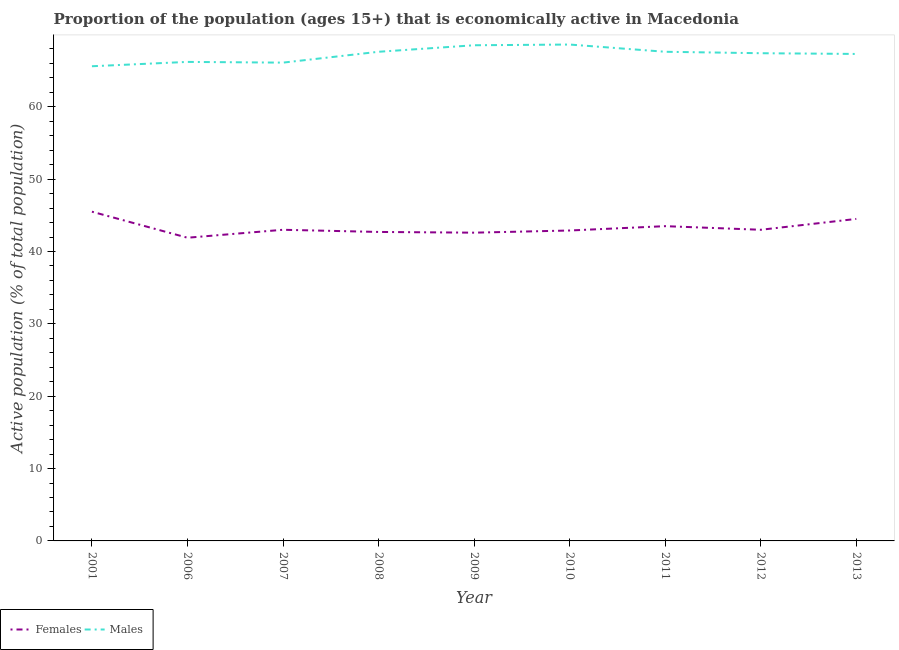How many different coloured lines are there?
Your response must be concise. 2. Does the line corresponding to percentage of economically active female population intersect with the line corresponding to percentage of economically active male population?
Provide a succinct answer. No. Is the number of lines equal to the number of legend labels?
Your answer should be compact. Yes. What is the percentage of economically active female population in 2011?
Make the answer very short. 43.5. Across all years, what is the maximum percentage of economically active male population?
Provide a succinct answer. 68.6. Across all years, what is the minimum percentage of economically active male population?
Offer a terse response. 65.6. In which year was the percentage of economically active female population maximum?
Provide a short and direct response. 2001. In which year was the percentage of economically active female population minimum?
Give a very brief answer. 2006. What is the total percentage of economically active male population in the graph?
Give a very brief answer. 604.9. What is the difference between the percentage of economically active male population in 2008 and that in 2013?
Ensure brevity in your answer.  0.3. What is the difference between the percentage of economically active male population in 2009 and the percentage of economically active female population in 2006?
Make the answer very short. 26.6. What is the average percentage of economically active female population per year?
Offer a terse response. 43.29. In the year 2012, what is the difference between the percentage of economically active male population and percentage of economically active female population?
Offer a very short reply. 24.4. What is the ratio of the percentage of economically active female population in 2008 to that in 2010?
Offer a terse response. 1. What is the difference between the highest and the second highest percentage of economically active male population?
Give a very brief answer. 0.1. What is the difference between the highest and the lowest percentage of economically active male population?
Ensure brevity in your answer.  3. In how many years, is the percentage of economically active male population greater than the average percentage of economically active male population taken over all years?
Make the answer very short. 6. Does the percentage of economically active male population monotonically increase over the years?
Give a very brief answer. No. Is the percentage of economically active male population strictly greater than the percentage of economically active female population over the years?
Keep it short and to the point. Yes. How many years are there in the graph?
Your answer should be compact. 9. What is the difference between two consecutive major ticks on the Y-axis?
Keep it short and to the point. 10. Does the graph contain any zero values?
Your response must be concise. No. Does the graph contain grids?
Your answer should be compact. No. Where does the legend appear in the graph?
Provide a succinct answer. Bottom left. What is the title of the graph?
Make the answer very short. Proportion of the population (ages 15+) that is economically active in Macedonia. Does "Electricity and heat production" appear as one of the legend labels in the graph?
Your answer should be compact. No. What is the label or title of the Y-axis?
Keep it short and to the point. Active population (% of total population). What is the Active population (% of total population) of Females in 2001?
Ensure brevity in your answer.  45.5. What is the Active population (% of total population) of Males in 2001?
Keep it short and to the point. 65.6. What is the Active population (% of total population) in Females in 2006?
Provide a short and direct response. 41.9. What is the Active population (% of total population) in Males in 2006?
Give a very brief answer. 66.2. What is the Active population (% of total population) of Females in 2007?
Offer a very short reply. 43. What is the Active population (% of total population) of Males in 2007?
Your answer should be very brief. 66.1. What is the Active population (% of total population) of Females in 2008?
Your answer should be compact. 42.7. What is the Active population (% of total population) of Males in 2008?
Your answer should be very brief. 67.6. What is the Active population (% of total population) in Females in 2009?
Make the answer very short. 42.6. What is the Active population (% of total population) in Males in 2009?
Provide a short and direct response. 68.5. What is the Active population (% of total population) of Females in 2010?
Ensure brevity in your answer.  42.9. What is the Active population (% of total population) in Males in 2010?
Provide a short and direct response. 68.6. What is the Active population (% of total population) in Females in 2011?
Ensure brevity in your answer.  43.5. What is the Active population (% of total population) of Males in 2011?
Your answer should be very brief. 67.6. What is the Active population (% of total population) of Females in 2012?
Offer a terse response. 43. What is the Active population (% of total population) in Males in 2012?
Make the answer very short. 67.4. What is the Active population (% of total population) of Females in 2013?
Offer a very short reply. 44.5. What is the Active population (% of total population) of Males in 2013?
Make the answer very short. 67.3. Across all years, what is the maximum Active population (% of total population) in Females?
Make the answer very short. 45.5. Across all years, what is the maximum Active population (% of total population) in Males?
Your answer should be compact. 68.6. Across all years, what is the minimum Active population (% of total population) in Females?
Offer a terse response. 41.9. Across all years, what is the minimum Active population (% of total population) of Males?
Provide a succinct answer. 65.6. What is the total Active population (% of total population) in Females in the graph?
Your response must be concise. 389.6. What is the total Active population (% of total population) of Males in the graph?
Provide a succinct answer. 604.9. What is the difference between the Active population (% of total population) of Females in 2001 and that in 2006?
Provide a short and direct response. 3.6. What is the difference between the Active population (% of total population) in Females in 2001 and that in 2007?
Your answer should be compact. 2.5. What is the difference between the Active population (% of total population) in Females in 2001 and that in 2008?
Provide a succinct answer. 2.8. What is the difference between the Active population (% of total population) of Males in 2001 and that in 2008?
Offer a terse response. -2. What is the difference between the Active population (% of total population) of Females in 2001 and that in 2012?
Give a very brief answer. 2.5. What is the difference between the Active population (% of total population) of Males in 2001 and that in 2012?
Provide a succinct answer. -1.8. What is the difference between the Active population (% of total population) of Males in 2001 and that in 2013?
Offer a very short reply. -1.7. What is the difference between the Active population (% of total population) in Males in 2006 and that in 2007?
Give a very brief answer. 0.1. What is the difference between the Active population (% of total population) in Males in 2006 and that in 2008?
Your answer should be very brief. -1.4. What is the difference between the Active population (% of total population) of Females in 2006 and that in 2009?
Make the answer very short. -0.7. What is the difference between the Active population (% of total population) of Males in 2006 and that in 2010?
Make the answer very short. -2.4. What is the difference between the Active population (% of total population) of Females in 2006 and that in 2012?
Make the answer very short. -1.1. What is the difference between the Active population (% of total population) in Males in 2006 and that in 2012?
Provide a succinct answer. -1.2. What is the difference between the Active population (% of total population) in Males in 2006 and that in 2013?
Provide a succinct answer. -1.1. What is the difference between the Active population (% of total population) of Females in 2007 and that in 2008?
Ensure brevity in your answer.  0.3. What is the difference between the Active population (% of total population) of Females in 2007 and that in 2010?
Your answer should be compact. 0.1. What is the difference between the Active population (% of total population) of Males in 2007 and that in 2011?
Provide a succinct answer. -1.5. What is the difference between the Active population (% of total population) of Females in 2007 and that in 2012?
Provide a short and direct response. 0. What is the difference between the Active population (% of total population) of Males in 2007 and that in 2012?
Keep it short and to the point. -1.3. What is the difference between the Active population (% of total population) in Females in 2007 and that in 2013?
Make the answer very short. -1.5. What is the difference between the Active population (% of total population) in Males in 2007 and that in 2013?
Ensure brevity in your answer.  -1.2. What is the difference between the Active population (% of total population) of Females in 2008 and that in 2009?
Your answer should be compact. 0.1. What is the difference between the Active population (% of total population) in Females in 2008 and that in 2011?
Your response must be concise. -0.8. What is the difference between the Active population (% of total population) in Males in 2008 and that in 2013?
Offer a very short reply. 0.3. What is the difference between the Active population (% of total population) in Males in 2009 and that in 2013?
Ensure brevity in your answer.  1.2. What is the difference between the Active population (% of total population) in Females in 2010 and that in 2011?
Your answer should be very brief. -0.6. What is the difference between the Active population (% of total population) in Males in 2010 and that in 2011?
Offer a very short reply. 1. What is the difference between the Active population (% of total population) of Males in 2010 and that in 2013?
Make the answer very short. 1.3. What is the difference between the Active population (% of total population) in Males in 2011 and that in 2012?
Keep it short and to the point. 0.2. What is the difference between the Active population (% of total population) of Females in 2011 and that in 2013?
Keep it short and to the point. -1. What is the difference between the Active population (% of total population) in Males in 2012 and that in 2013?
Give a very brief answer. 0.1. What is the difference between the Active population (% of total population) in Females in 2001 and the Active population (% of total population) in Males in 2006?
Give a very brief answer. -20.7. What is the difference between the Active population (% of total population) in Females in 2001 and the Active population (% of total population) in Males in 2007?
Offer a terse response. -20.6. What is the difference between the Active population (% of total population) in Females in 2001 and the Active population (% of total population) in Males in 2008?
Your response must be concise. -22.1. What is the difference between the Active population (% of total population) of Females in 2001 and the Active population (% of total population) of Males in 2010?
Ensure brevity in your answer.  -23.1. What is the difference between the Active population (% of total population) in Females in 2001 and the Active population (% of total population) in Males in 2011?
Your answer should be compact. -22.1. What is the difference between the Active population (% of total population) in Females in 2001 and the Active population (% of total population) in Males in 2012?
Ensure brevity in your answer.  -21.9. What is the difference between the Active population (% of total population) in Females in 2001 and the Active population (% of total population) in Males in 2013?
Provide a succinct answer. -21.8. What is the difference between the Active population (% of total population) in Females in 2006 and the Active population (% of total population) in Males in 2007?
Ensure brevity in your answer.  -24.2. What is the difference between the Active population (% of total population) in Females in 2006 and the Active population (% of total population) in Males in 2008?
Your answer should be compact. -25.7. What is the difference between the Active population (% of total population) of Females in 2006 and the Active population (% of total population) of Males in 2009?
Offer a very short reply. -26.6. What is the difference between the Active population (% of total population) in Females in 2006 and the Active population (% of total population) in Males in 2010?
Offer a very short reply. -26.7. What is the difference between the Active population (% of total population) of Females in 2006 and the Active population (% of total population) of Males in 2011?
Ensure brevity in your answer.  -25.7. What is the difference between the Active population (% of total population) in Females in 2006 and the Active population (% of total population) in Males in 2012?
Provide a succinct answer. -25.5. What is the difference between the Active population (% of total population) of Females in 2006 and the Active population (% of total population) of Males in 2013?
Keep it short and to the point. -25.4. What is the difference between the Active population (% of total population) in Females in 2007 and the Active population (% of total population) in Males in 2008?
Offer a very short reply. -24.6. What is the difference between the Active population (% of total population) in Females in 2007 and the Active population (% of total population) in Males in 2009?
Your response must be concise. -25.5. What is the difference between the Active population (% of total population) in Females in 2007 and the Active population (% of total population) in Males in 2010?
Your response must be concise. -25.6. What is the difference between the Active population (% of total population) of Females in 2007 and the Active population (% of total population) of Males in 2011?
Give a very brief answer. -24.6. What is the difference between the Active population (% of total population) in Females in 2007 and the Active population (% of total population) in Males in 2012?
Give a very brief answer. -24.4. What is the difference between the Active population (% of total population) in Females in 2007 and the Active population (% of total population) in Males in 2013?
Your response must be concise. -24.3. What is the difference between the Active population (% of total population) in Females in 2008 and the Active population (% of total population) in Males in 2009?
Your answer should be very brief. -25.8. What is the difference between the Active population (% of total population) of Females in 2008 and the Active population (% of total population) of Males in 2010?
Make the answer very short. -25.9. What is the difference between the Active population (% of total population) of Females in 2008 and the Active population (% of total population) of Males in 2011?
Provide a succinct answer. -24.9. What is the difference between the Active population (% of total population) in Females in 2008 and the Active population (% of total population) in Males in 2012?
Your answer should be very brief. -24.7. What is the difference between the Active population (% of total population) in Females in 2008 and the Active population (% of total population) in Males in 2013?
Your response must be concise. -24.6. What is the difference between the Active population (% of total population) of Females in 2009 and the Active population (% of total population) of Males in 2010?
Offer a very short reply. -26. What is the difference between the Active population (% of total population) of Females in 2009 and the Active population (% of total population) of Males in 2012?
Offer a terse response. -24.8. What is the difference between the Active population (% of total population) in Females in 2009 and the Active population (% of total population) in Males in 2013?
Offer a very short reply. -24.7. What is the difference between the Active population (% of total population) in Females in 2010 and the Active population (% of total population) in Males in 2011?
Offer a terse response. -24.7. What is the difference between the Active population (% of total population) in Females in 2010 and the Active population (% of total population) in Males in 2012?
Provide a succinct answer. -24.5. What is the difference between the Active population (% of total population) in Females in 2010 and the Active population (% of total population) in Males in 2013?
Make the answer very short. -24.4. What is the difference between the Active population (% of total population) in Females in 2011 and the Active population (% of total population) in Males in 2012?
Make the answer very short. -23.9. What is the difference between the Active population (% of total population) in Females in 2011 and the Active population (% of total population) in Males in 2013?
Provide a succinct answer. -23.8. What is the difference between the Active population (% of total population) of Females in 2012 and the Active population (% of total population) of Males in 2013?
Offer a terse response. -24.3. What is the average Active population (% of total population) of Females per year?
Your answer should be compact. 43.29. What is the average Active population (% of total population) of Males per year?
Give a very brief answer. 67.21. In the year 2001, what is the difference between the Active population (% of total population) of Females and Active population (% of total population) of Males?
Give a very brief answer. -20.1. In the year 2006, what is the difference between the Active population (% of total population) of Females and Active population (% of total population) of Males?
Provide a succinct answer. -24.3. In the year 2007, what is the difference between the Active population (% of total population) of Females and Active population (% of total population) of Males?
Your response must be concise. -23.1. In the year 2008, what is the difference between the Active population (% of total population) in Females and Active population (% of total population) in Males?
Give a very brief answer. -24.9. In the year 2009, what is the difference between the Active population (% of total population) of Females and Active population (% of total population) of Males?
Keep it short and to the point. -25.9. In the year 2010, what is the difference between the Active population (% of total population) in Females and Active population (% of total population) in Males?
Your answer should be very brief. -25.7. In the year 2011, what is the difference between the Active population (% of total population) of Females and Active population (% of total population) of Males?
Keep it short and to the point. -24.1. In the year 2012, what is the difference between the Active population (% of total population) in Females and Active population (% of total population) in Males?
Keep it short and to the point. -24.4. In the year 2013, what is the difference between the Active population (% of total population) of Females and Active population (% of total population) of Males?
Make the answer very short. -22.8. What is the ratio of the Active population (% of total population) in Females in 2001 to that in 2006?
Provide a short and direct response. 1.09. What is the ratio of the Active population (% of total population) in Males in 2001 to that in 2006?
Offer a very short reply. 0.99. What is the ratio of the Active population (% of total population) in Females in 2001 to that in 2007?
Provide a succinct answer. 1.06. What is the ratio of the Active population (% of total population) in Females in 2001 to that in 2008?
Provide a succinct answer. 1.07. What is the ratio of the Active population (% of total population) of Males in 2001 to that in 2008?
Your answer should be compact. 0.97. What is the ratio of the Active population (% of total population) of Females in 2001 to that in 2009?
Your response must be concise. 1.07. What is the ratio of the Active population (% of total population) of Males in 2001 to that in 2009?
Your response must be concise. 0.96. What is the ratio of the Active population (% of total population) of Females in 2001 to that in 2010?
Your answer should be compact. 1.06. What is the ratio of the Active population (% of total population) of Males in 2001 to that in 2010?
Provide a short and direct response. 0.96. What is the ratio of the Active population (% of total population) of Females in 2001 to that in 2011?
Provide a succinct answer. 1.05. What is the ratio of the Active population (% of total population) of Males in 2001 to that in 2011?
Provide a short and direct response. 0.97. What is the ratio of the Active population (% of total population) in Females in 2001 to that in 2012?
Your answer should be compact. 1.06. What is the ratio of the Active population (% of total population) of Males in 2001 to that in 2012?
Your response must be concise. 0.97. What is the ratio of the Active population (% of total population) in Females in 2001 to that in 2013?
Ensure brevity in your answer.  1.02. What is the ratio of the Active population (% of total population) in Males in 2001 to that in 2013?
Provide a succinct answer. 0.97. What is the ratio of the Active population (% of total population) of Females in 2006 to that in 2007?
Offer a very short reply. 0.97. What is the ratio of the Active population (% of total population) of Females in 2006 to that in 2008?
Offer a very short reply. 0.98. What is the ratio of the Active population (% of total population) of Males in 2006 to that in 2008?
Make the answer very short. 0.98. What is the ratio of the Active population (% of total population) of Females in 2006 to that in 2009?
Provide a succinct answer. 0.98. What is the ratio of the Active population (% of total population) in Males in 2006 to that in 2009?
Your answer should be very brief. 0.97. What is the ratio of the Active population (% of total population) of Females in 2006 to that in 2010?
Provide a succinct answer. 0.98. What is the ratio of the Active population (% of total population) of Males in 2006 to that in 2010?
Your answer should be very brief. 0.96. What is the ratio of the Active population (% of total population) of Females in 2006 to that in 2011?
Keep it short and to the point. 0.96. What is the ratio of the Active population (% of total population) in Males in 2006 to that in 2011?
Give a very brief answer. 0.98. What is the ratio of the Active population (% of total population) of Females in 2006 to that in 2012?
Keep it short and to the point. 0.97. What is the ratio of the Active population (% of total population) in Males in 2006 to that in 2012?
Your response must be concise. 0.98. What is the ratio of the Active population (% of total population) of Females in 2006 to that in 2013?
Offer a terse response. 0.94. What is the ratio of the Active population (% of total population) in Males in 2006 to that in 2013?
Make the answer very short. 0.98. What is the ratio of the Active population (% of total population) in Females in 2007 to that in 2008?
Offer a terse response. 1.01. What is the ratio of the Active population (% of total population) of Males in 2007 to that in 2008?
Make the answer very short. 0.98. What is the ratio of the Active population (% of total population) of Females in 2007 to that in 2009?
Your answer should be very brief. 1.01. What is the ratio of the Active population (% of total population) in Males in 2007 to that in 2010?
Offer a very short reply. 0.96. What is the ratio of the Active population (% of total population) in Females in 2007 to that in 2011?
Make the answer very short. 0.99. What is the ratio of the Active population (% of total population) of Males in 2007 to that in 2011?
Keep it short and to the point. 0.98. What is the ratio of the Active population (% of total population) of Females in 2007 to that in 2012?
Provide a short and direct response. 1. What is the ratio of the Active population (% of total population) of Males in 2007 to that in 2012?
Offer a very short reply. 0.98. What is the ratio of the Active population (% of total population) in Females in 2007 to that in 2013?
Provide a succinct answer. 0.97. What is the ratio of the Active population (% of total population) in Males in 2007 to that in 2013?
Provide a succinct answer. 0.98. What is the ratio of the Active population (% of total population) of Females in 2008 to that in 2009?
Offer a terse response. 1. What is the ratio of the Active population (% of total population) in Males in 2008 to that in 2009?
Your answer should be very brief. 0.99. What is the ratio of the Active population (% of total population) in Females in 2008 to that in 2010?
Offer a very short reply. 1. What is the ratio of the Active population (% of total population) in Males in 2008 to that in 2010?
Keep it short and to the point. 0.99. What is the ratio of the Active population (% of total population) in Females in 2008 to that in 2011?
Your response must be concise. 0.98. What is the ratio of the Active population (% of total population) of Males in 2008 to that in 2012?
Give a very brief answer. 1. What is the ratio of the Active population (% of total population) in Females in 2008 to that in 2013?
Offer a very short reply. 0.96. What is the ratio of the Active population (% of total population) in Females in 2009 to that in 2010?
Give a very brief answer. 0.99. What is the ratio of the Active population (% of total population) of Females in 2009 to that in 2011?
Make the answer very short. 0.98. What is the ratio of the Active population (% of total population) in Males in 2009 to that in 2011?
Ensure brevity in your answer.  1.01. What is the ratio of the Active population (% of total population) of Males in 2009 to that in 2012?
Provide a succinct answer. 1.02. What is the ratio of the Active population (% of total population) in Females in 2009 to that in 2013?
Your answer should be compact. 0.96. What is the ratio of the Active population (% of total population) of Males in 2009 to that in 2013?
Offer a terse response. 1.02. What is the ratio of the Active population (% of total population) of Females in 2010 to that in 2011?
Your answer should be compact. 0.99. What is the ratio of the Active population (% of total population) in Males in 2010 to that in 2011?
Provide a short and direct response. 1.01. What is the ratio of the Active population (% of total population) in Females in 2010 to that in 2012?
Keep it short and to the point. 1. What is the ratio of the Active population (% of total population) of Males in 2010 to that in 2012?
Make the answer very short. 1.02. What is the ratio of the Active population (% of total population) in Males in 2010 to that in 2013?
Offer a terse response. 1.02. What is the ratio of the Active population (% of total population) of Females in 2011 to that in 2012?
Keep it short and to the point. 1.01. What is the ratio of the Active population (% of total population) of Females in 2011 to that in 2013?
Offer a terse response. 0.98. What is the ratio of the Active population (% of total population) of Females in 2012 to that in 2013?
Your answer should be very brief. 0.97. What is the difference between the highest and the second highest Active population (% of total population) of Males?
Make the answer very short. 0.1. 